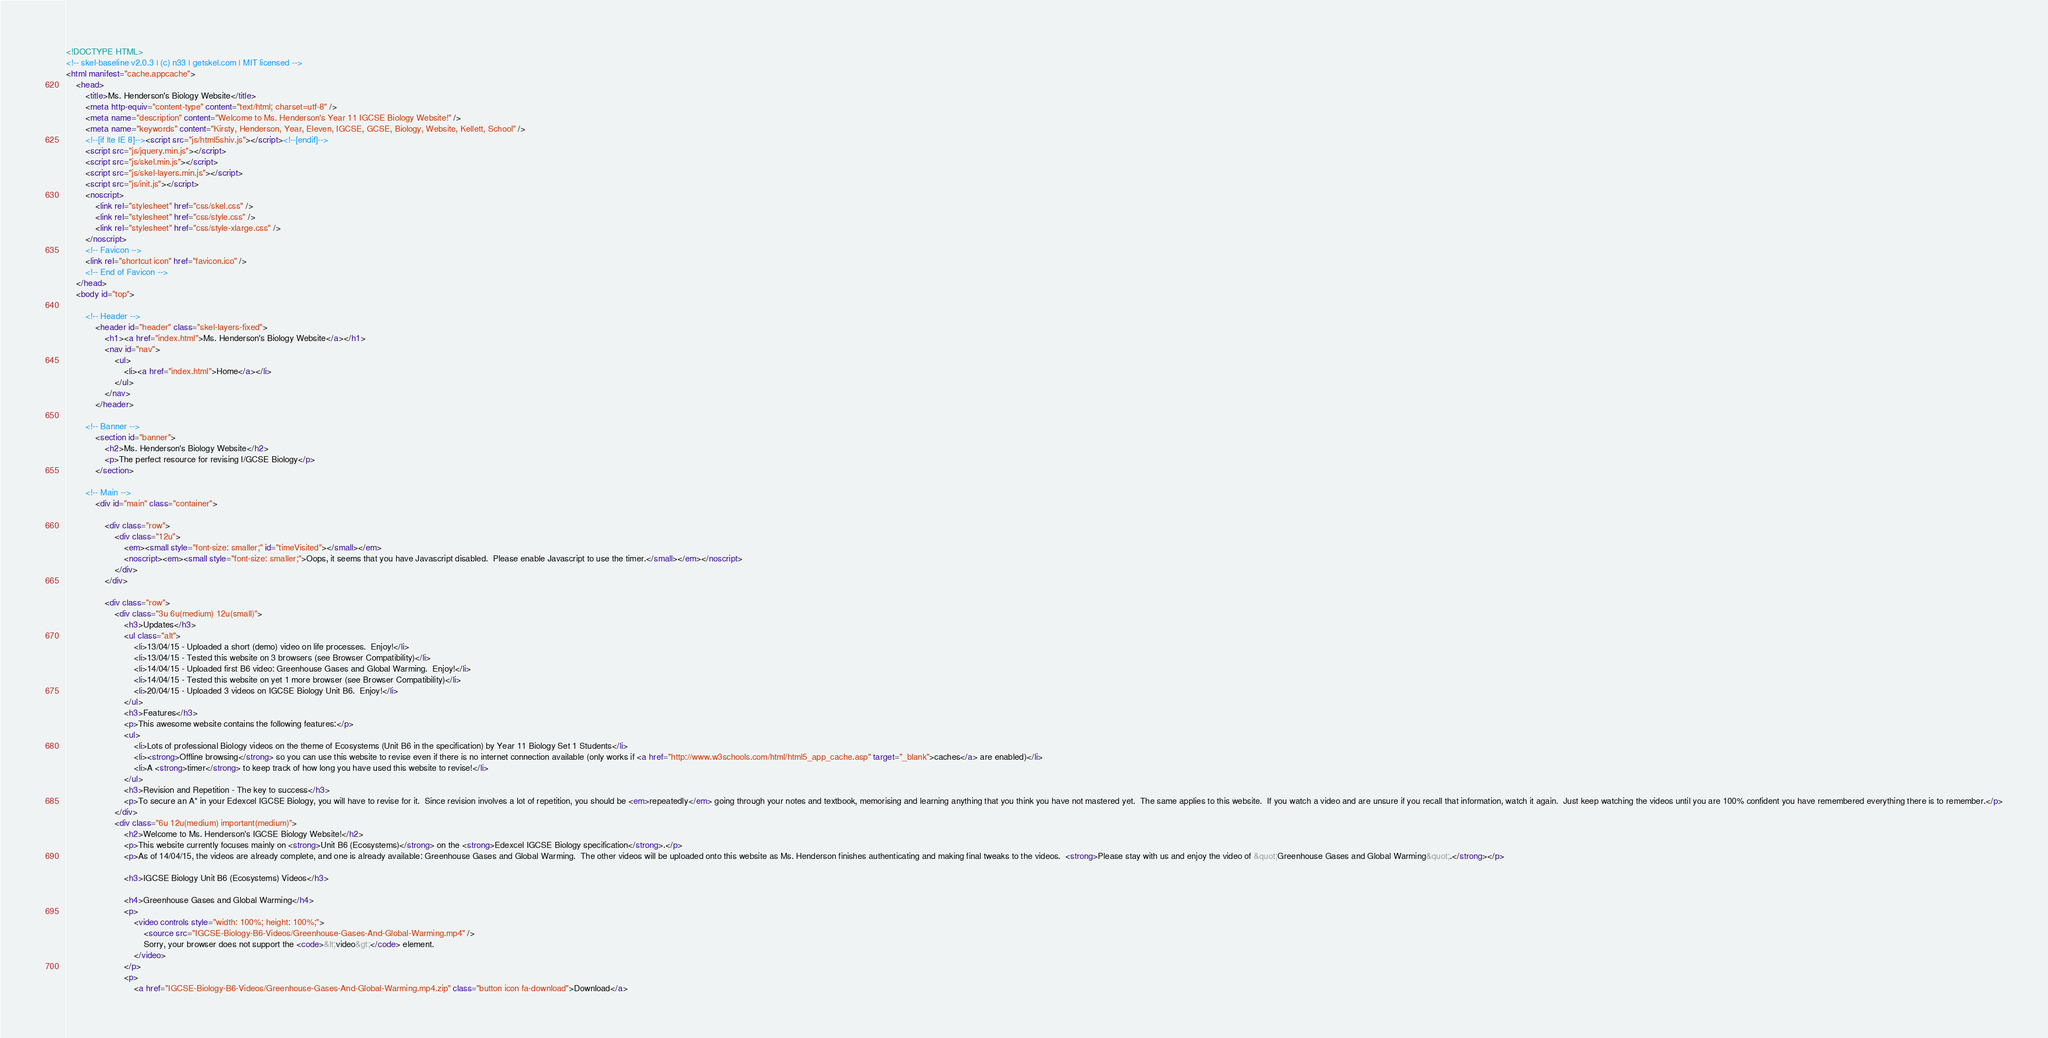<code> <loc_0><loc_0><loc_500><loc_500><_HTML_><!DOCTYPE HTML>
<!-- skel-baseline v2.0.3 | (c) n33 | getskel.com | MIT licensed -->
<html manifest="cache.appcache">
	<head>
		<title>Ms. Henderson's Biology Website</title>
		<meta http-equiv="content-type" content="text/html; charset=utf-8" />
		<meta name="description" content="Welcome to Ms. Henderson's Year 11 IGCSE Biology Website!" />
		<meta name="keywords" content="Kirsty, Henderson, Year, Eleven, IGCSE, GCSE, Biology, Website, Kellett, School" />
		<!--[if lte IE 8]--><script src="js/html5shiv.js"></script><!--[endif]-->
		<script src="js/jquery.min.js"></script>
		<script src="js/skel.min.js"></script>
		<script src="js/skel-layers.min.js"></script>
		<script src="js/init.js"></script>
		<noscript>
			<link rel="stylesheet" href="css/skel.css" />
			<link rel="stylesheet" href="css/style.css" />
			<link rel="stylesheet" href="css/style-xlarge.css" />
		</noscript>
		<!-- Favicon -->
		<link rel="shortcut icon" href="favicon.ico" />
		<!-- End of Favicon -->
	</head>
	<body id="top">

		<!-- Header -->
			<header id="header" class="skel-layers-fixed">
				<h1><a href="index.html">Ms. Henderson's Biology Website</a></h1>
				<nav id="nav">
					<ul>
						<li><a href="index.html">Home</a></li>
					</ul>
				</nav>
			</header>

		<!-- Banner -->
			<section id="banner">
				<h2>Ms. Henderson's Biology Website</h2>
				<p>The perfect resource for revising I/GCSE Biology</p>
			</section>

		<!-- Main -->
			<div id="main" class="container">

				<div class="row">
					<div class="12u">
						<em><small style="font-size: smaller;" id="timeVisited"></small></em>
						<noscript><em><small style="font-size: smaller;">Oops, it seems that you have Javascript disabled.  Please enable Javascript to use the timer.</small></em></noscript>	
					</div>
				</div>

				<div class="row">
					<div class="3u 6u(medium) 12u(small)">
						<h3>Updates</h3>
						<ul class="alt">
							<li>13/04/15 - Uploaded a short (demo) video on life processes.  Enjoy!</li>
							<li>13/04/15 - Tested this website on 3 browsers (see Browser Compatibility)</li>
							<li>14/04/15 - Uploaded first B6 video: Greenhouse Gases and Global Warming.  Enjoy!</li>
							<li>14/04/15 - Tested this website on yet 1 more browser (see Browser Compatibility)</li>
							<li>20/04/15 - Uploaded 3 videos on IGCSE Biology Unit B6.  Enjoy!</li>
						</ul>
						<h3>Features</h3>
						<p>This awesome website contains the following features:</p>
						<ul>
							<li>Lots of professional Biology videos on the theme of Ecosystems (Unit B6 in the specification) by Year 11 Biology Set 1 Students</li>
							<li><strong>Offline browsing</strong> so you can use this website to revise even if there is no internet connection available (only works if <a href="http://www.w3schools.com/html/html5_app_cache.asp" target="_blank">caches</a> are enabled)</li>
							<li>A <strong>timer</strong> to keep track of how long you have used this website to revise!</li>
						</ul>
						<h3>Revision and Repetition - The key to success</h3>
						<p>To secure an A* in your Edexcel IGCSE Biology, you will have to revise for it.  Since revision involves a lot of repetition, you should be <em>repeatedly</em> going through your notes and textbook, memorising and learning anything that you think you have not mastered yet.  The same applies to this website.  If you watch a video and are unsure if you recall that information, watch it again.  Just keep watching the videos until you are 100% confident you have remembered everything there is to remember.</p>
					</div>
					<div class="6u 12u(medium) important(medium)">
						<h2>Welcome to Ms. Henderson's IGCSE Biology Website!</h2>
						<p>This website currently focuses mainly on <strong>Unit B6 (Ecosystems)</strong> on the <strong>Edexcel IGCSE Biology specification</strong>.</p>
						<p>As of 14/04/15, the videos are already complete, and one is already available: Greenhouse Gases and Global Warming.  The other videos will be uploaded onto this website as Ms. Henderson finishes authenticating and making final tweaks to the videos.  <strong>Please stay with us and enjoy the video of &quot;Greenhouse Gases and Global Warming&quot;.</strong></p>

						<h3>IGCSE Biology Unit B6 (Ecosystems) Videos</h3>

						<h4>Greenhouse Gases and Global Warming</h4>
						<p>
							<video controls style="width: 100%; height: 100%;">
								<source src="IGCSE-Biology-B6-Videos/Greenhouse-Gases-And-Global-Warming.mp4" />
								Sorry, your browser does not support the <code>&lt;video&gt;</code> element.
							</video>
						</p>
						<p>
							<a href="IGCSE-Biology-B6-Videos/Greenhouse-Gases-And-Global-Warming.mp4.zip" class="button icon fa-download">Download</a></code> 